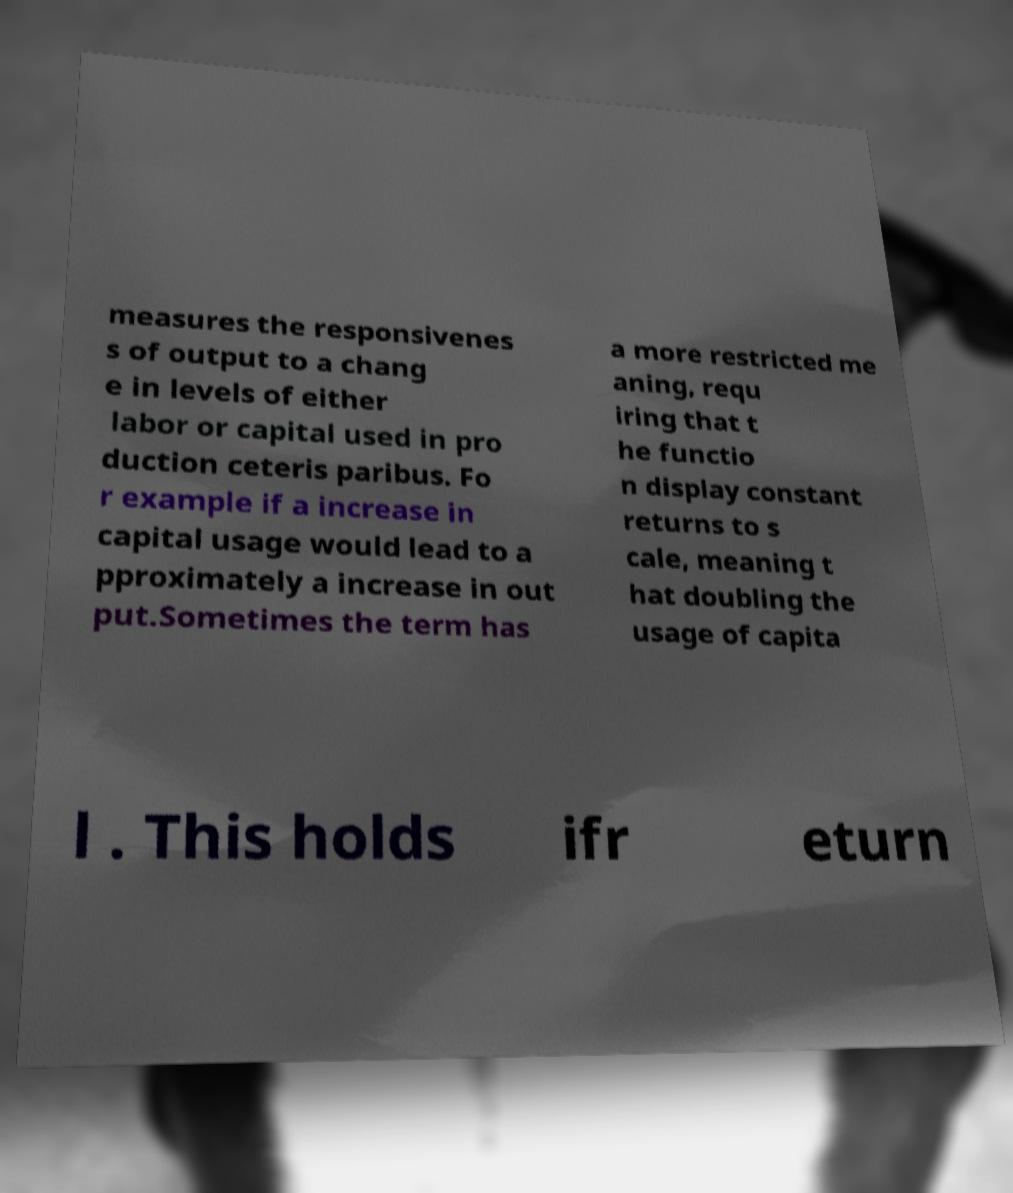Could you extract and type out the text from this image? measures the responsivenes s of output to a chang e in levels of either labor or capital used in pro duction ceteris paribus. Fo r example if a increase in capital usage would lead to a pproximately a increase in out put.Sometimes the term has a more restricted me aning, requ iring that t he functio n display constant returns to s cale, meaning t hat doubling the usage of capita l . This holds ifr eturn 